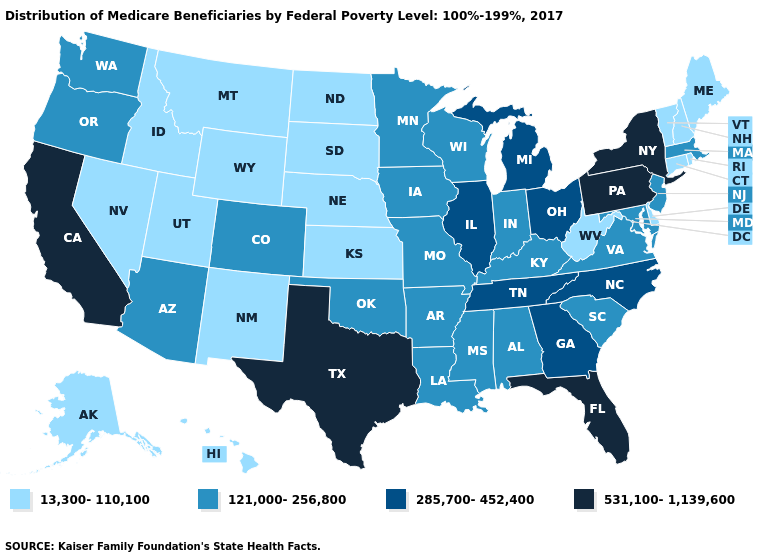Does California have the highest value in the USA?
Concise answer only. Yes. Does Delaware have the lowest value in the South?
Write a very short answer. Yes. What is the highest value in states that border Indiana?
Give a very brief answer. 285,700-452,400. Name the states that have a value in the range 285,700-452,400?
Answer briefly. Georgia, Illinois, Michigan, North Carolina, Ohio, Tennessee. Does West Virginia have a higher value than South Carolina?
Concise answer only. No. Name the states that have a value in the range 121,000-256,800?
Give a very brief answer. Alabama, Arizona, Arkansas, Colorado, Indiana, Iowa, Kentucky, Louisiana, Maryland, Massachusetts, Minnesota, Mississippi, Missouri, New Jersey, Oklahoma, Oregon, South Carolina, Virginia, Washington, Wisconsin. Among the states that border Ohio , does West Virginia have the lowest value?
Keep it brief. Yes. Among the states that border Idaho , does Oregon have the highest value?
Short answer required. Yes. Which states hav the highest value in the South?
Be succinct. Florida, Texas. What is the value of Minnesota?
Give a very brief answer. 121,000-256,800. What is the value of Hawaii?
Concise answer only. 13,300-110,100. What is the highest value in the MidWest ?
Quick response, please. 285,700-452,400. Does Massachusetts have the lowest value in the Northeast?
Give a very brief answer. No. What is the value of Missouri?
Give a very brief answer. 121,000-256,800. What is the value of Nevada?
Short answer required. 13,300-110,100. 